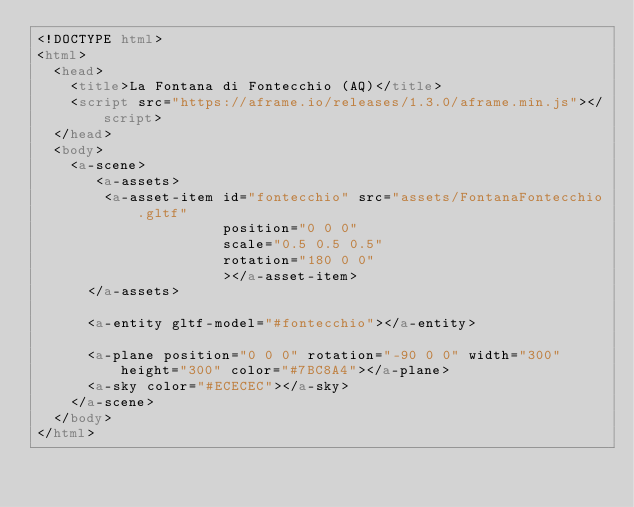Convert code to text. <code><loc_0><loc_0><loc_500><loc_500><_HTML_><!DOCTYPE html>
<html>
  <head>
    <title>La Fontana di Fontecchio (AQ)</title>
    <script src="https://aframe.io/releases/1.3.0/aframe.min.js"></script>
  </head>
  <body>
    <a-scene>
       <a-assets>
        <a-asset-item id="fontecchio" src="assets/FontanaFontecchio.gltf" 
                      position="0 0 0" 
                      scale="0.5 0.5 0.5"
                      rotation="180 0 0" 
                      ></a-asset-item>
      </a-assets>

      <a-entity gltf-model="#fontecchio"></a-entity>

      <a-plane position="0 0 0" rotation="-90 0 0" width="300" height="300" color="#7BC8A4"></a-plane>
      <a-sky color="#ECECEC"></a-sky>
    </a-scene>
  </body>
</html>
</code> 